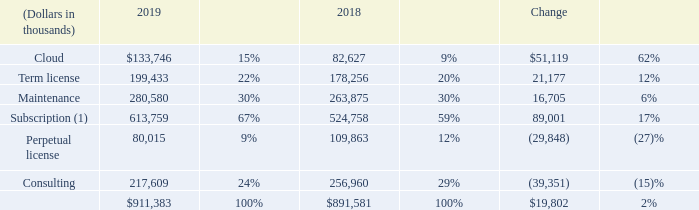RESULTS OF OPERATIONS
Revenue
(1) Reflects client arrangements (term license, cloud, and maintenance) that are subject to renewal.
We expect our revenue mix to continue to shift in favor of our subscription offerings, particularly cloud arrangements, which could result in slower total revenue growth in the near term. Revenue from cloud arrangements is generally recognized over the service period, while revenue from term and perpetual license arrangements is generally recognized upfront when the license rights become effective.
Subscription revenue
The increase in cloud revenue in 2019 reflects the shift in client preferences to cloud arrangements from other types of arrangements. The increase in term license revenue in 2019 was due to several large, multi-year term license contracts executed in 2019. This increase was partially offset by term license contracts with multi-year committed maintenance periods, where a greater portion of the contract value is allocated to maintenance.
The increase in maintenance revenue in 2019 was primarily due to the continued growth in the aggregate value of the installed base of our software and strong renewal rates in excess of 90%
Perpetual license
The decrease in perpetual license revenue in 2019 reflects the shift in client preferences in favor of our subscription offerings, particularly cloud arrangements
Consulting
Our consulting revenue fluctuates depending upon the mix of new implementation projects we perform as compared to those performed by our enabled clients or led by our partners. See "Our consulting revenue is significantly dependent upon our consulting personnel implementing new license and cloud arrangements" in Item 1A of this Annual Report for additional information.
The decrease in consulting revenue in 2019 was primarily due to a decrease in billable hours.
How is revenue from cloud arrangements recognised? Recognized over the service period. How is revenue from term and perpetual license arrangements recognised? Recognized upfront when the license rights become effective. What can the increase in maintenance revenue in 2019 be primarily attributed to? The continued growth in the aggregate value of the installed base of our software and strong renewal rates in excess of 90%. What is the percentage change in revenue from Cloud services between 2018 and 2019?
Answer scale should be: percent. (133,746 - 82,627)/82,627 
Answer: 61.87. What is the percentage change in revenue from term license between 2018 and 2019?
Answer scale should be: percent. (199,433 - 178,256)/178,256 
Answer: 11.88. What is the percentage change in revenue from maintenance between 2018 and 2019?
Answer scale should be: percent. (280,580 - 263,875)/263,875 
Answer: 6.33. 